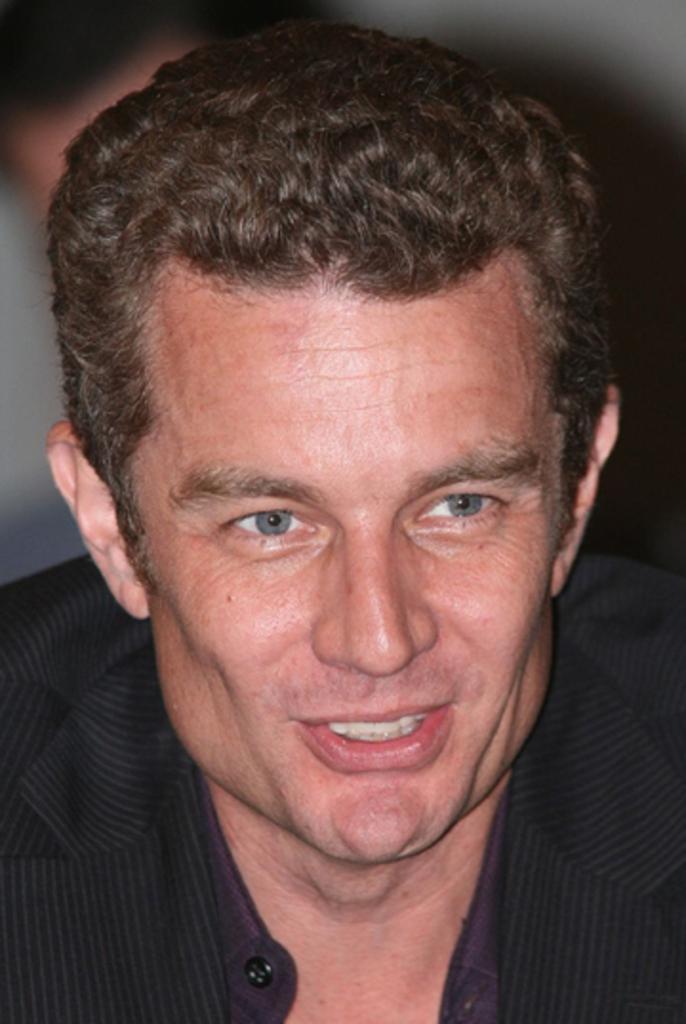Can you describe this image briefly? In this picture we can see a man's face, there is a blurry background. 